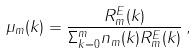<formula> <loc_0><loc_0><loc_500><loc_500>\mu _ { m } ( k ) = \frac { R _ { m } ^ { E } ( k ) } { \Sigma _ { k = 0 } ^ { m } n _ { m } ( k ) R _ { m } ^ { E } ( k ) } \, ,</formula> 